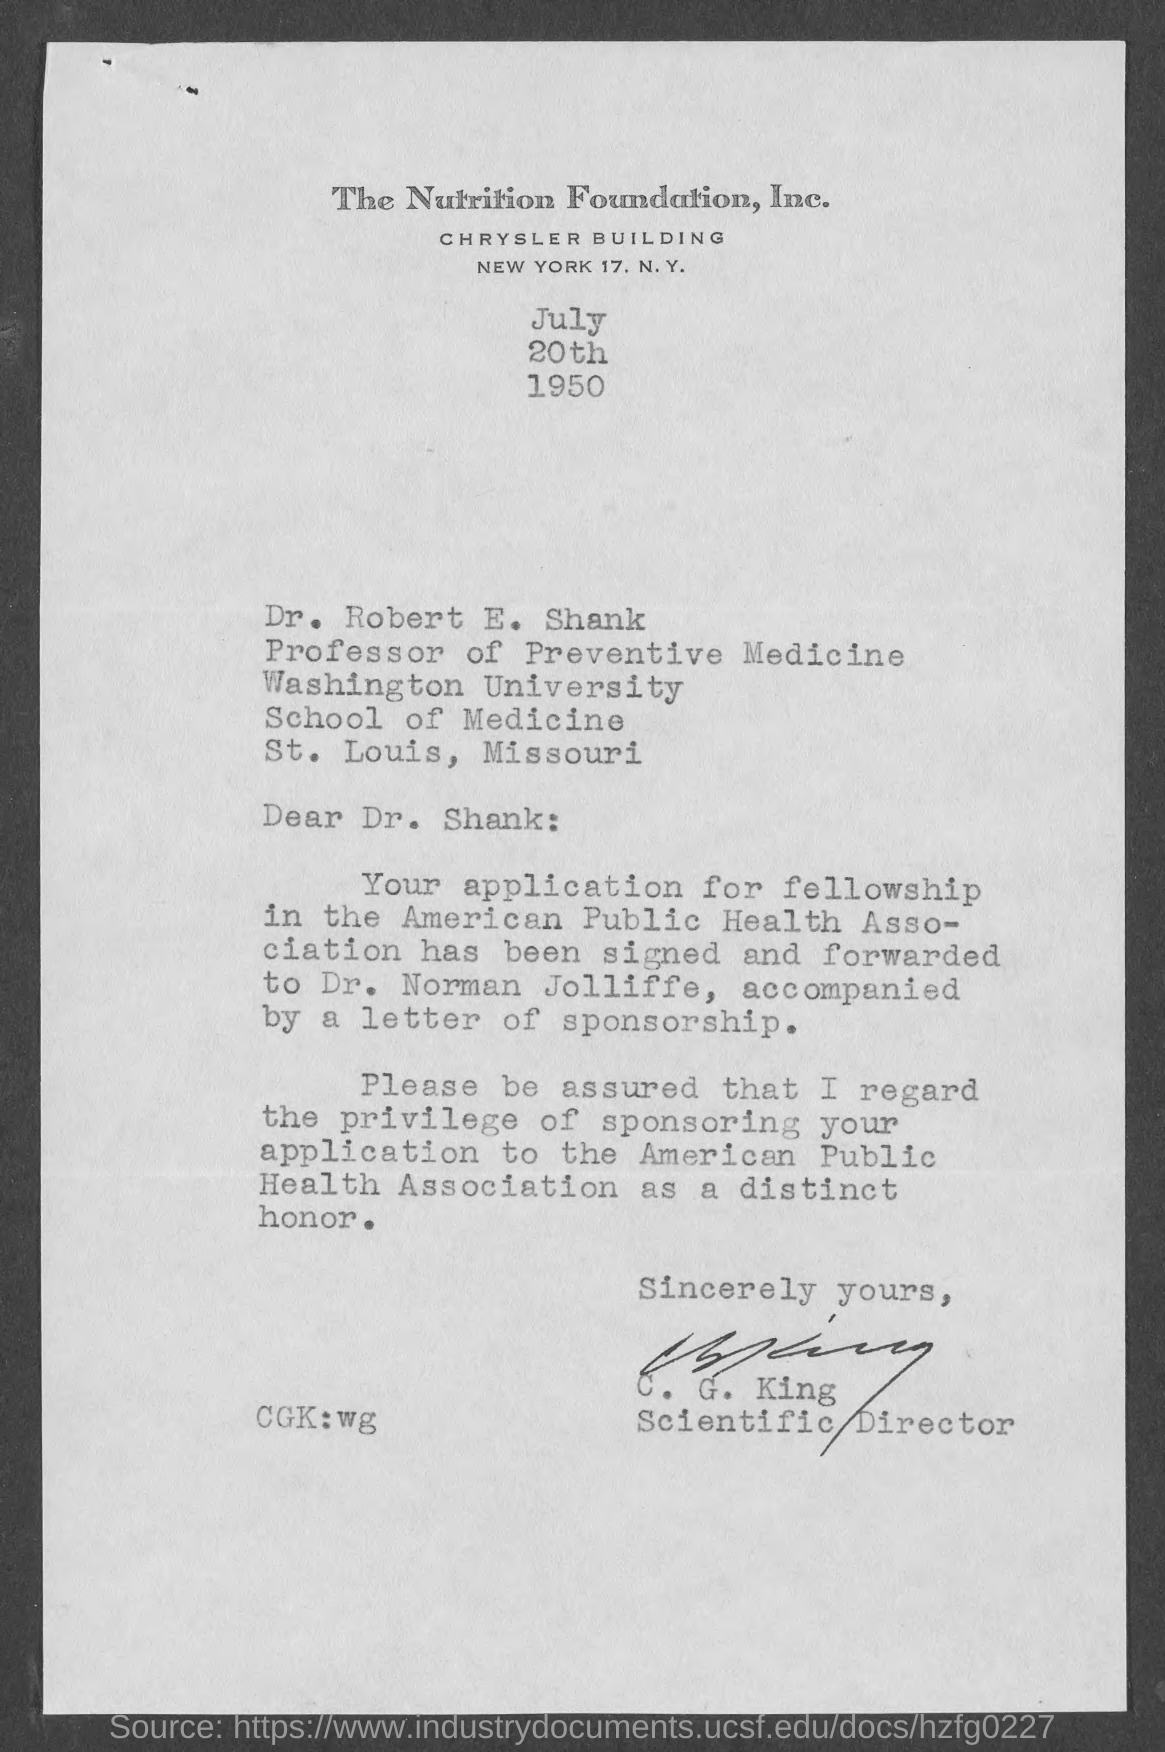Draw attention to some important aspects in this diagram. Dr. Robert E. Shank holds the designation of professor of preventive medicine. The date mentioned in the given letter is July 20th, 1950. The letter ended with the signature of "C.G. King. C.G. King's designation is Scientific Director. 